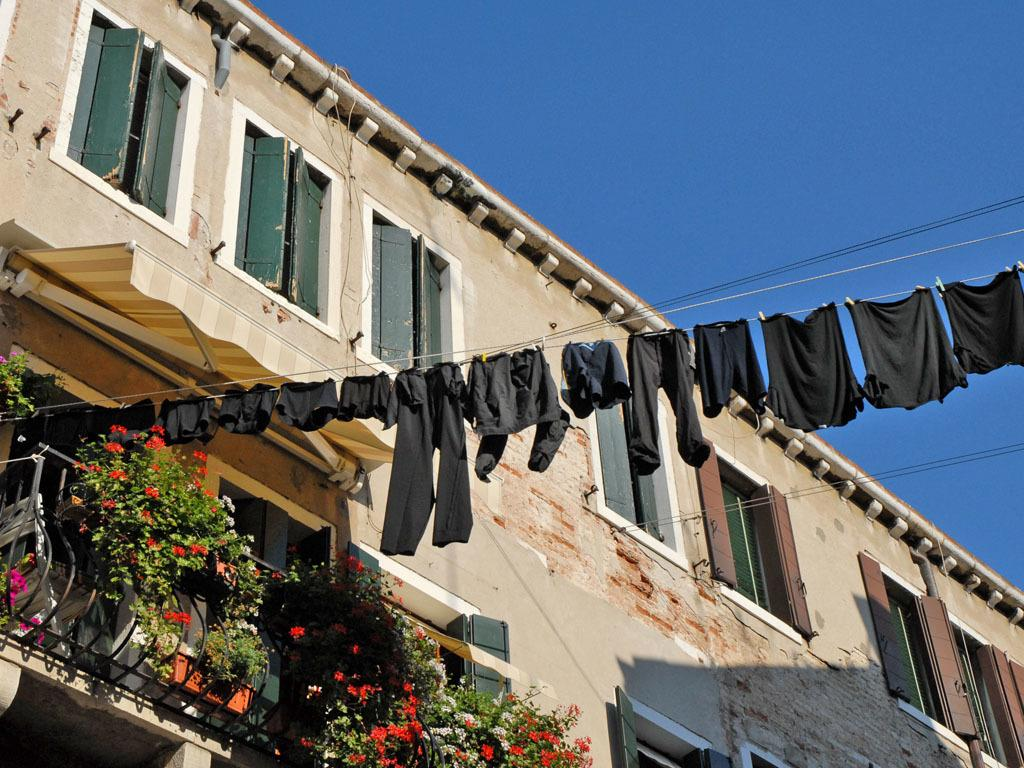What is hanging on the rope in the image? There are clothes dried on a rope in the image. What can be seen in the background of the image? There is a building visible in the background of the image. How does the doll feel about the fear of heights in the image? There is no doll present in the image, and therefore no such emotions or fears can be observed. 